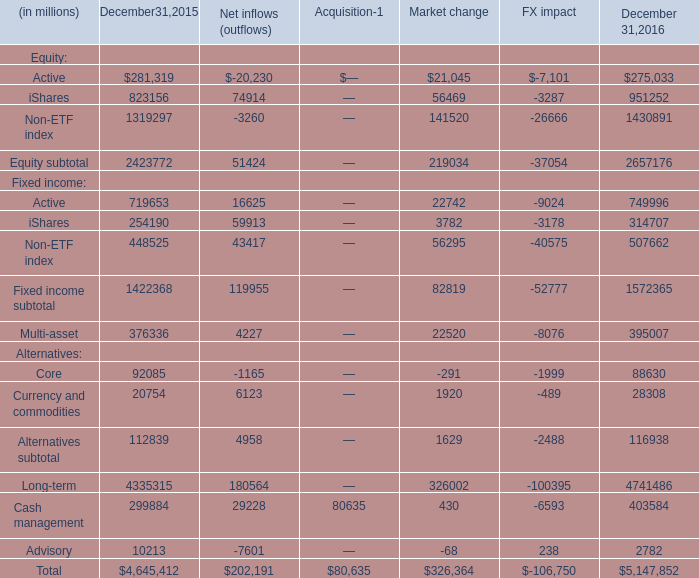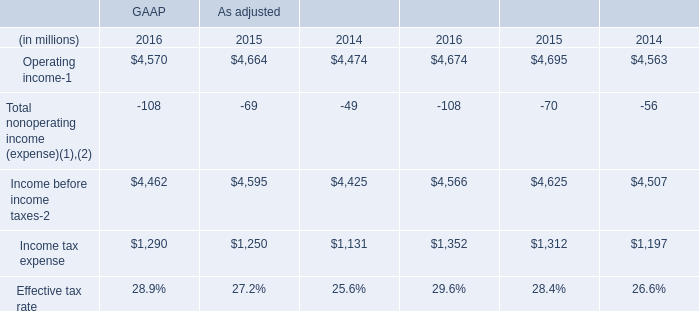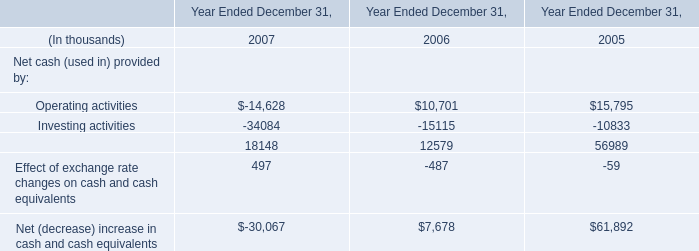what's the total amount of iShares of December 31,2016, Operating income of GAAP 2016, and Operating income of As adjusted 2016 ? 
Computations: ((951252.0 + 4570.0) + 4674.0)
Answer: 960496.0. 